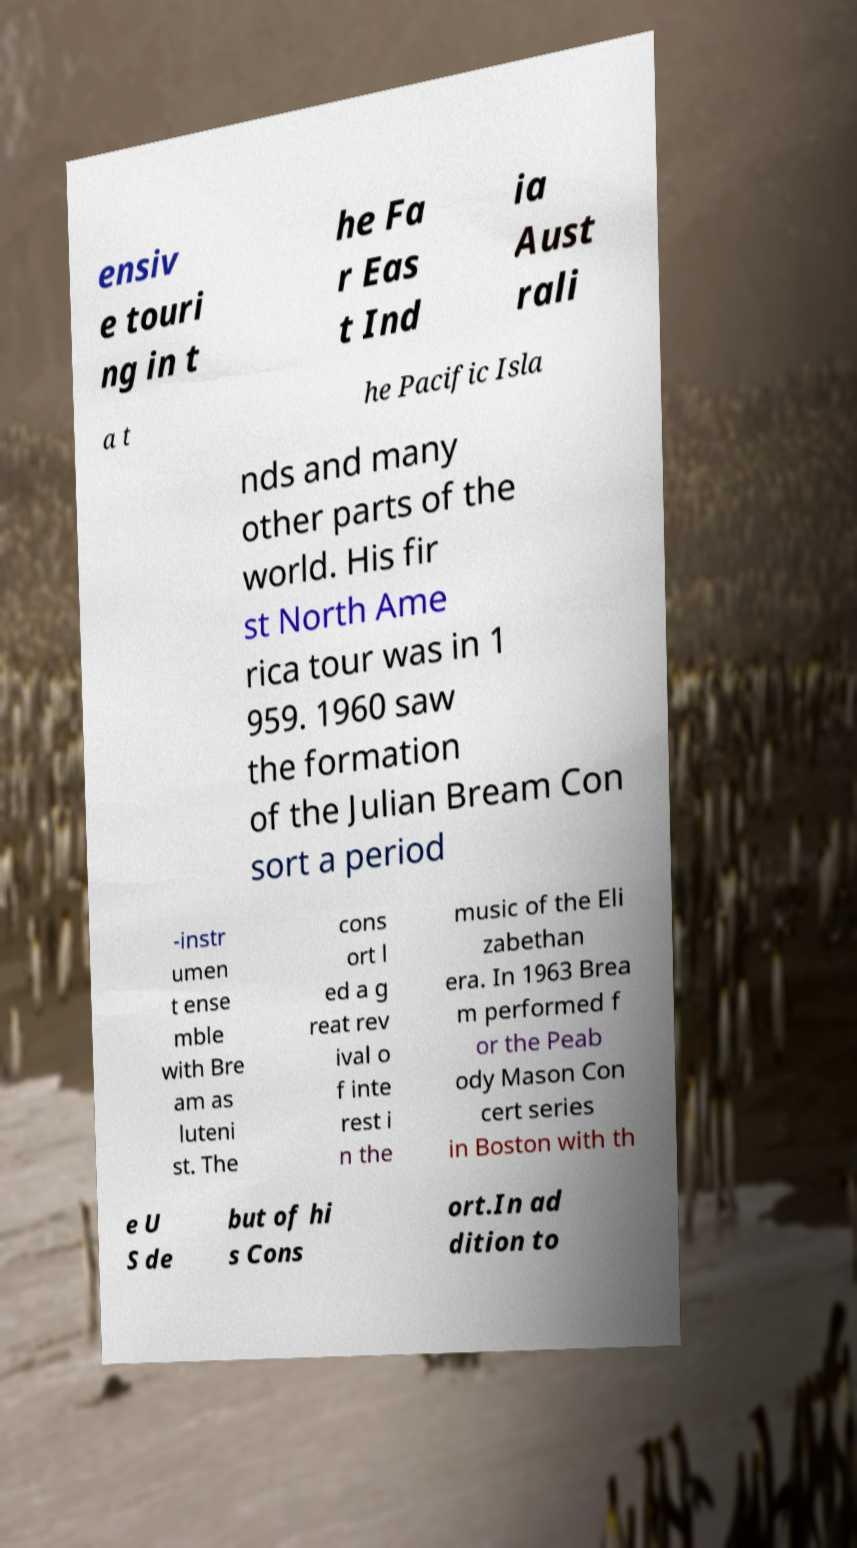There's text embedded in this image that I need extracted. Can you transcribe it verbatim? ensiv e touri ng in t he Fa r Eas t Ind ia Aust rali a t he Pacific Isla nds and many other parts of the world. His fir st North Ame rica tour was in 1 959. 1960 saw the formation of the Julian Bream Con sort a period -instr umen t ense mble with Bre am as luteni st. The cons ort l ed a g reat rev ival o f inte rest i n the music of the Eli zabethan era. In 1963 Brea m performed f or the Peab ody Mason Con cert series in Boston with th e U S de but of hi s Cons ort.In ad dition to 